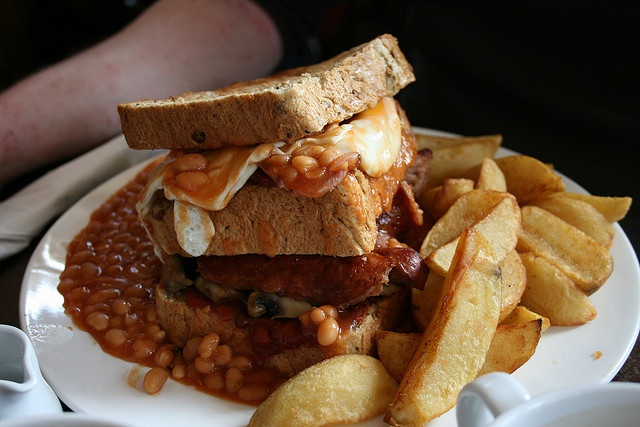Describe the objects in this image and their specific colors. I can see sandwich in black, maroon, and brown tones, people in black, brown, gray, and maroon tones, cup in black, darkgray, and lightgray tones, and dining table in black, darkgray, and gray tones in this image. 